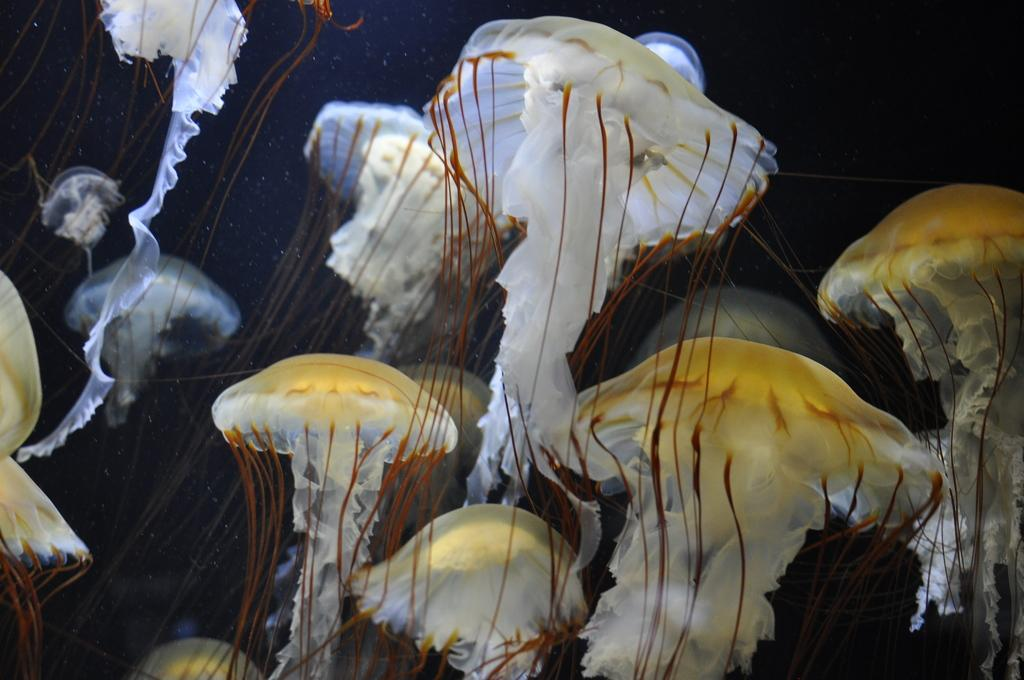What type of sea creatures are in the image? There are jellyfishes in the image. Where are the jellyfishes located? The jellyfishes are underwater. Can you describe the position of the jellyfishes in the image? The jellyfishes are in the center of the image. What type of wrench is being used to attempt to fix the scene in the image? There is no wrench or attempt to fix anything in the image; it features jellyfishes underwater. 